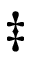<formula> <loc_0><loc_0><loc_500><loc_500>\ddagger</formula> 